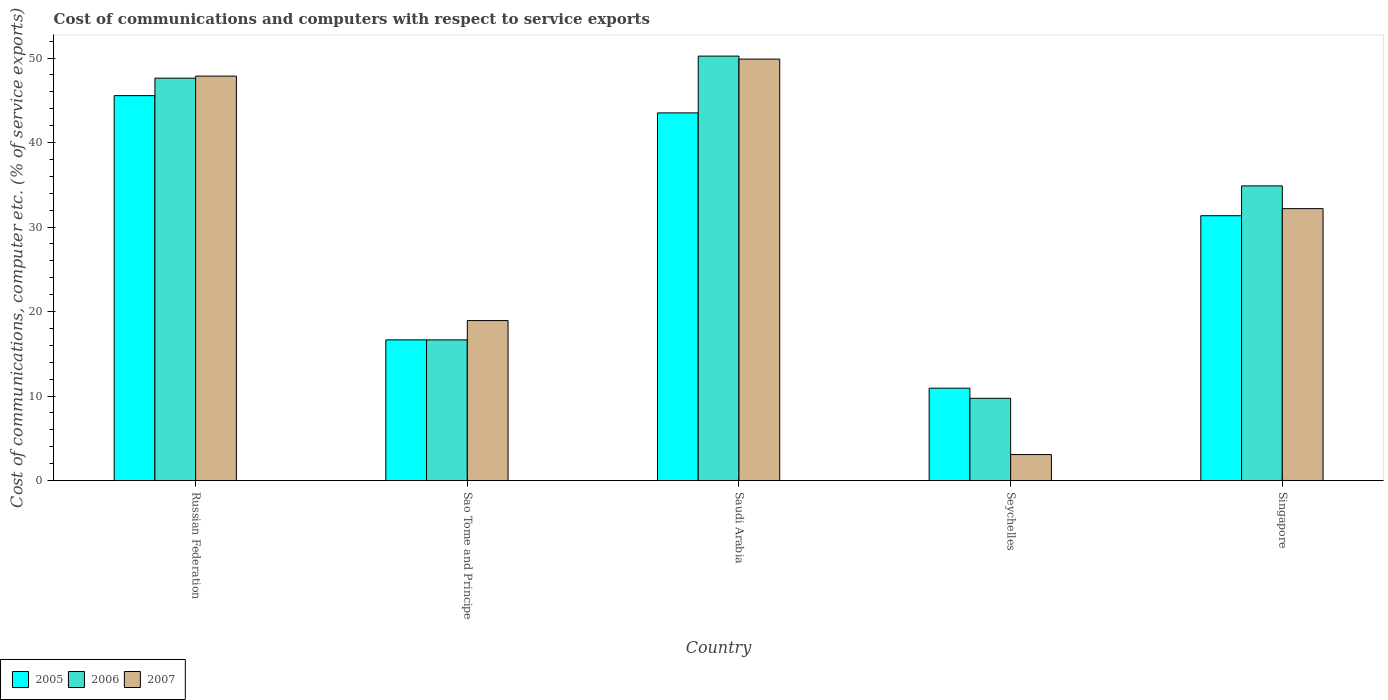Are the number of bars per tick equal to the number of legend labels?
Keep it short and to the point. Yes. How many bars are there on the 3rd tick from the left?
Give a very brief answer. 3. How many bars are there on the 3rd tick from the right?
Provide a short and direct response. 3. What is the label of the 4th group of bars from the left?
Provide a short and direct response. Seychelles. In how many cases, is the number of bars for a given country not equal to the number of legend labels?
Ensure brevity in your answer.  0. What is the cost of communications and computers in 2005 in Sao Tome and Principe?
Keep it short and to the point. 16.65. Across all countries, what is the maximum cost of communications and computers in 2006?
Offer a very short reply. 50.22. Across all countries, what is the minimum cost of communications and computers in 2006?
Your answer should be very brief. 9.74. In which country was the cost of communications and computers in 2006 maximum?
Keep it short and to the point. Saudi Arabia. In which country was the cost of communications and computers in 2007 minimum?
Keep it short and to the point. Seychelles. What is the total cost of communications and computers in 2007 in the graph?
Your answer should be very brief. 151.91. What is the difference between the cost of communications and computers in 2005 in Sao Tome and Principe and that in Saudi Arabia?
Provide a succinct answer. -26.86. What is the difference between the cost of communications and computers in 2006 in Singapore and the cost of communications and computers in 2007 in Russian Federation?
Provide a succinct answer. -12.99. What is the average cost of communications and computers in 2006 per country?
Your answer should be compact. 31.82. What is the difference between the cost of communications and computers of/in 2005 and cost of communications and computers of/in 2006 in Seychelles?
Offer a terse response. 1.2. In how many countries, is the cost of communications and computers in 2007 greater than 4 %?
Give a very brief answer. 4. What is the ratio of the cost of communications and computers in 2005 in Russian Federation to that in Sao Tome and Principe?
Ensure brevity in your answer.  2.74. Is the difference between the cost of communications and computers in 2005 in Saudi Arabia and Singapore greater than the difference between the cost of communications and computers in 2006 in Saudi Arabia and Singapore?
Your answer should be very brief. No. What is the difference between the highest and the second highest cost of communications and computers in 2007?
Your answer should be very brief. -17.69. What is the difference between the highest and the lowest cost of communications and computers in 2006?
Your response must be concise. 40.49. What does the 3rd bar from the right in Sao Tome and Principe represents?
Offer a terse response. 2005. Are all the bars in the graph horizontal?
Ensure brevity in your answer.  No. What is the difference between two consecutive major ticks on the Y-axis?
Provide a short and direct response. 10. Are the values on the major ticks of Y-axis written in scientific E-notation?
Provide a succinct answer. No. Where does the legend appear in the graph?
Keep it short and to the point. Bottom left. How are the legend labels stacked?
Your answer should be compact. Horizontal. What is the title of the graph?
Your response must be concise. Cost of communications and computers with respect to service exports. Does "1974" appear as one of the legend labels in the graph?
Ensure brevity in your answer.  No. What is the label or title of the X-axis?
Keep it short and to the point. Country. What is the label or title of the Y-axis?
Ensure brevity in your answer.  Cost of communications, computer etc. (% of service exports). What is the Cost of communications, computer etc. (% of service exports) of 2005 in Russian Federation?
Your answer should be very brief. 45.55. What is the Cost of communications, computer etc. (% of service exports) of 2006 in Russian Federation?
Provide a short and direct response. 47.61. What is the Cost of communications, computer etc. (% of service exports) of 2007 in Russian Federation?
Provide a succinct answer. 47.86. What is the Cost of communications, computer etc. (% of service exports) in 2005 in Sao Tome and Principe?
Give a very brief answer. 16.65. What is the Cost of communications, computer etc. (% of service exports) in 2006 in Sao Tome and Principe?
Provide a succinct answer. 16.65. What is the Cost of communications, computer etc. (% of service exports) of 2007 in Sao Tome and Principe?
Offer a terse response. 18.93. What is the Cost of communications, computer etc. (% of service exports) in 2005 in Saudi Arabia?
Keep it short and to the point. 43.5. What is the Cost of communications, computer etc. (% of service exports) in 2006 in Saudi Arabia?
Keep it short and to the point. 50.22. What is the Cost of communications, computer etc. (% of service exports) of 2007 in Saudi Arabia?
Provide a succinct answer. 49.87. What is the Cost of communications, computer etc. (% of service exports) in 2005 in Seychelles?
Your answer should be compact. 10.93. What is the Cost of communications, computer etc. (% of service exports) of 2006 in Seychelles?
Your answer should be very brief. 9.74. What is the Cost of communications, computer etc. (% of service exports) of 2007 in Seychelles?
Provide a short and direct response. 3.08. What is the Cost of communications, computer etc. (% of service exports) of 2005 in Singapore?
Give a very brief answer. 31.34. What is the Cost of communications, computer etc. (% of service exports) of 2006 in Singapore?
Give a very brief answer. 34.87. What is the Cost of communications, computer etc. (% of service exports) of 2007 in Singapore?
Make the answer very short. 32.18. Across all countries, what is the maximum Cost of communications, computer etc. (% of service exports) in 2005?
Keep it short and to the point. 45.55. Across all countries, what is the maximum Cost of communications, computer etc. (% of service exports) of 2006?
Ensure brevity in your answer.  50.22. Across all countries, what is the maximum Cost of communications, computer etc. (% of service exports) of 2007?
Make the answer very short. 49.87. Across all countries, what is the minimum Cost of communications, computer etc. (% of service exports) in 2005?
Offer a terse response. 10.93. Across all countries, what is the minimum Cost of communications, computer etc. (% of service exports) of 2006?
Your answer should be very brief. 9.74. Across all countries, what is the minimum Cost of communications, computer etc. (% of service exports) in 2007?
Offer a very short reply. 3.08. What is the total Cost of communications, computer etc. (% of service exports) of 2005 in the graph?
Your answer should be compact. 147.97. What is the total Cost of communications, computer etc. (% of service exports) of 2006 in the graph?
Provide a short and direct response. 159.09. What is the total Cost of communications, computer etc. (% of service exports) in 2007 in the graph?
Give a very brief answer. 151.91. What is the difference between the Cost of communications, computer etc. (% of service exports) in 2005 in Russian Federation and that in Sao Tome and Principe?
Offer a terse response. 28.9. What is the difference between the Cost of communications, computer etc. (% of service exports) of 2006 in Russian Federation and that in Sao Tome and Principe?
Offer a terse response. 30.97. What is the difference between the Cost of communications, computer etc. (% of service exports) of 2007 in Russian Federation and that in Sao Tome and Principe?
Keep it short and to the point. 28.92. What is the difference between the Cost of communications, computer etc. (% of service exports) in 2005 in Russian Federation and that in Saudi Arabia?
Your answer should be compact. 2.04. What is the difference between the Cost of communications, computer etc. (% of service exports) in 2006 in Russian Federation and that in Saudi Arabia?
Your answer should be compact. -2.61. What is the difference between the Cost of communications, computer etc. (% of service exports) in 2007 in Russian Federation and that in Saudi Arabia?
Offer a terse response. -2.01. What is the difference between the Cost of communications, computer etc. (% of service exports) in 2005 in Russian Federation and that in Seychelles?
Ensure brevity in your answer.  34.61. What is the difference between the Cost of communications, computer etc. (% of service exports) of 2006 in Russian Federation and that in Seychelles?
Ensure brevity in your answer.  37.88. What is the difference between the Cost of communications, computer etc. (% of service exports) of 2007 in Russian Federation and that in Seychelles?
Keep it short and to the point. 44.78. What is the difference between the Cost of communications, computer etc. (% of service exports) in 2005 in Russian Federation and that in Singapore?
Offer a terse response. 14.21. What is the difference between the Cost of communications, computer etc. (% of service exports) of 2006 in Russian Federation and that in Singapore?
Offer a terse response. 12.75. What is the difference between the Cost of communications, computer etc. (% of service exports) in 2007 in Russian Federation and that in Singapore?
Keep it short and to the point. 15.68. What is the difference between the Cost of communications, computer etc. (% of service exports) in 2005 in Sao Tome and Principe and that in Saudi Arabia?
Provide a succinct answer. -26.86. What is the difference between the Cost of communications, computer etc. (% of service exports) of 2006 in Sao Tome and Principe and that in Saudi Arabia?
Your response must be concise. -33.58. What is the difference between the Cost of communications, computer etc. (% of service exports) of 2007 in Sao Tome and Principe and that in Saudi Arabia?
Make the answer very short. -30.94. What is the difference between the Cost of communications, computer etc. (% of service exports) in 2005 in Sao Tome and Principe and that in Seychelles?
Provide a succinct answer. 5.72. What is the difference between the Cost of communications, computer etc. (% of service exports) in 2006 in Sao Tome and Principe and that in Seychelles?
Your answer should be compact. 6.91. What is the difference between the Cost of communications, computer etc. (% of service exports) of 2007 in Sao Tome and Principe and that in Seychelles?
Your response must be concise. 15.86. What is the difference between the Cost of communications, computer etc. (% of service exports) of 2005 in Sao Tome and Principe and that in Singapore?
Offer a very short reply. -14.69. What is the difference between the Cost of communications, computer etc. (% of service exports) of 2006 in Sao Tome and Principe and that in Singapore?
Keep it short and to the point. -18.22. What is the difference between the Cost of communications, computer etc. (% of service exports) in 2007 in Sao Tome and Principe and that in Singapore?
Offer a very short reply. -13.24. What is the difference between the Cost of communications, computer etc. (% of service exports) of 2005 in Saudi Arabia and that in Seychelles?
Ensure brevity in your answer.  32.57. What is the difference between the Cost of communications, computer etc. (% of service exports) in 2006 in Saudi Arabia and that in Seychelles?
Your answer should be compact. 40.49. What is the difference between the Cost of communications, computer etc. (% of service exports) in 2007 in Saudi Arabia and that in Seychelles?
Your answer should be very brief. 46.79. What is the difference between the Cost of communications, computer etc. (% of service exports) of 2005 in Saudi Arabia and that in Singapore?
Give a very brief answer. 12.17. What is the difference between the Cost of communications, computer etc. (% of service exports) in 2006 in Saudi Arabia and that in Singapore?
Your response must be concise. 15.36. What is the difference between the Cost of communications, computer etc. (% of service exports) in 2007 in Saudi Arabia and that in Singapore?
Your response must be concise. 17.69. What is the difference between the Cost of communications, computer etc. (% of service exports) of 2005 in Seychelles and that in Singapore?
Provide a succinct answer. -20.41. What is the difference between the Cost of communications, computer etc. (% of service exports) of 2006 in Seychelles and that in Singapore?
Offer a very short reply. -25.13. What is the difference between the Cost of communications, computer etc. (% of service exports) in 2007 in Seychelles and that in Singapore?
Provide a short and direct response. -29.1. What is the difference between the Cost of communications, computer etc. (% of service exports) in 2005 in Russian Federation and the Cost of communications, computer etc. (% of service exports) in 2006 in Sao Tome and Principe?
Your answer should be very brief. 28.9. What is the difference between the Cost of communications, computer etc. (% of service exports) of 2005 in Russian Federation and the Cost of communications, computer etc. (% of service exports) of 2007 in Sao Tome and Principe?
Ensure brevity in your answer.  26.61. What is the difference between the Cost of communications, computer etc. (% of service exports) of 2006 in Russian Federation and the Cost of communications, computer etc. (% of service exports) of 2007 in Sao Tome and Principe?
Your response must be concise. 28.68. What is the difference between the Cost of communications, computer etc. (% of service exports) in 2005 in Russian Federation and the Cost of communications, computer etc. (% of service exports) in 2006 in Saudi Arabia?
Your response must be concise. -4.68. What is the difference between the Cost of communications, computer etc. (% of service exports) of 2005 in Russian Federation and the Cost of communications, computer etc. (% of service exports) of 2007 in Saudi Arabia?
Give a very brief answer. -4.32. What is the difference between the Cost of communications, computer etc. (% of service exports) of 2006 in Russian Federation and the Cost of communications, computer etc. (% of service exports) of 2007 in Saudi Arabia?
Your answer should be compact. -2.26. What is the difference between the Cost of communications, computer etc. (% of service exports) in 2005 in Russian Federation and the Cost of communications, computer etc. (% of service exports) in 2006 in Seychelles?
Your response must be concise. 35.81. What is the difference between the Cost of communications, computer etc. (% of service exports) in 2005 in Russian Federation and the Cost of communications, computer etc. (% of service exports) in 2007 in Seychelles?
Make the answer very short. 42.47. What is the difference between the Cost of communications, computer etc. (% of service exports) of 2006 in Russian Federation and the Cost of communications, computer etc. (% of service exports) of 2007 in Seychelles?
Provide a short and direct response. 44.54. What is the difference between the Cost of communications, computer etc. (% of service exports) of 2005 in Russian Federation and the Cost of communications, computer etc. (% of service exports) of 2006 in Singapore?
Your answer should be compact. 10.68. What is the difference between the Cost of communications, computer etc. (% of service exports) of 2005 in Russian Federation and the Cost of communications, computer etc. (% of service exports) of 2007 in Singapore?
Your answer should be compact. 13.37. What is the difference between the Cost of communications, computer etc. (% of service exports) of 2006 in Russian Federation and the Cost of communications, computer etc. (% of service exports) of 2007 in Singapore?
Keep it short and to the point. 15.44. What is the difference between the Cost of communications, computer etc. (% of service exports) of 2005 in Sao Tome and Principe and the Cost of communications, computer etc. (% of service exports) of 2006 in Saudi Arabia?
Offer a terse response. -33.58. What is the difference between the Cost of communications, computer etc. (% of service exports) in 2005 in Sao Tome and Principe and the Cost of communications, computer etc. (% of service exports) in 2007 in Saudi Arabia?
Provide a succinct answer. -33.22. What is the difference between the Cost of communications, computer etc. (% of service exports) in 2006 in Sao Tome and Principe and the Cost of communications, computer etc. (% of service exports) in 2007 in Saudi Arabia?
Give a very brief answer. -33.22. What is the difference between the Cost of communications, computer etc. (% of service exports) of 2005 in Sao Tome and Principe and the Cost of communications, computer etc. (% of service exports) of 2006 in Seychelles?
Provide a short and direct response. 6.91. What is the difference between the Cost of communications, computer etc. (% of service exports) in 2005 in Sao Tome and Principe and the Cost of communications, computer etc. (% of service exports) in 2007 in Seychelles?
Provide a succinct answer. 13.57. What is the difference between the Cost of communications, computer etc. (% of service exports) in 2006 in Sao Tome and Principe and the Cost of communications, computer etc. (% of service exports) in 2007 in Seychelles?
Offer a very short reply. 13.57. What is the difference between the Cost of communications, computer etc. (% of service exports) in 2005 in Sao Tome and Principe and the Cost of communications, computer etc. (% of service exports) in 2006 in Singapore?
Offer a very short reply. -18.22. What is the difference between the Cost of communications, computer etc. (% of service exports) of 2005 in Sao Tome and Principe and the Cost of communications, computer etc. (% of service exports) of 2007 in Singapore?
Provide a short and direct response. -15.53. What is the difference between the Cost of communications, computer etc. (% of service exports) in 2006 in Sao Tome and Principe and the Cost of communications, computer etc. (% of service exports) in 2007 in Singapore?
Your answer should be compact. -15.53. What is the difference between the Cost of communications, computer etc. (% of service exports) in 2005 in Saudi Arabia and the Cost of communications, computer etc. (% of service exports) in 2006 in Seychelles?
Keep it short and to the point. 33.77. What is the difference between the Cost of communications, computer etc. (% of service exports) of 2005 in Saudi Arabia and the Cost of communications, computer etc. (% of service exports) of 2007 in Seychelles?
Provide a short and direct response. 40.43. What is the difference between the Cost of communications, computer etc. (% of service exports) of 2006 in Saudi Arabia and the Cost of communications, computer etc. (% of service exports) of 2007 in Seychelles?
Offer a terse response. 47.15. What is the difference between the Cost of communications, computer etc. (% of service exports) of 2005 in Saudi Arabia and the Cost of communications, computer etc. (% of service exports) of 2006 in Singapore?
Your response must be concise. 8.64. What is the difference between the Cost of communications, computer etc. (% of service exports) of 2005 in Saudi Arabia and the Cost of communications, computer etc. (% of service exports) of 2007 in Singapore?
Your answer should be compact. 11.33. What is the difference between the Cost of communications, computer etc. (% of service exports) in 2006 in Saudi Arabia and the Cost of communications, computer etc. (% of service exports) in 2007 in Singapore?
Offer a terse response. 18.05. What is the difference between the Cost of communications, computer etc. (% of service exports) in 2005 in Seychelles and the Cost of communications, computer etc. (% of service exports) in 2006 in Singapore?
Your answer should be compact. -23.94. What is the difference between the Cost of communications, computer etc. (% of service exports) in 2005 in Seychelles and the Cost of communications, computer etc. (% of service exports) in 2007 in Singapore?
Your response must be concise. -21.24. What is the difference between the Cost of communications, computer etc. (% of service exports) in 2006 in Seychelles and the Cost of communications, computer etc. (% of service exports) in 2007 in Singapore?
Make the answer very short. -22.44. What is the average Cost of communications, computer etc. (% of service exports) in 2005 per country?
Make the answer very short. 29.59. What is the average Cost of communications, computer etc. (% of service exports) of 2006 per country?
Give a very brief answer. 31.82. What is the average Cost of communications, computer etc. (% of service exports) in 2007 per country?
Your answer should be compact. 30.38. What is the difference between the Cost of communications, computer etc. (% of service exports) of 2005 and Cost of communications, computer etc. (% of service exports) of 2006 in Russian Federation?
Ensure brevity in your answer.  -2.07. What is the difference between the Cost of communications, computer etc. (% of service exports) of 2005 and Cost of communications, computer etc. (% of service exports) of 2007 in Russian Federation?
Offer a very short reply. -2.31. What is the difference between the Cost of communications, computer etc. (% of service exports) in 2006 and Cost of communications, computer etc. (% of service exports) in 2007 in Russian Federation?
Offer a very short reply. -0.24. What is the difference between the Cost of communications, computer etc. (% of service exports) in 2005 and Cost of communications, computer etc. (% of service exports) in 2007 in Sao Tome and Principe?
Keep it short and to the point. -2.29. What is the difference between the Cost of communications, computer etc. (% of service exports) of 2006 and Cost of communications, computer etc. (% of service exports) of 2007 in Sao Tome and Principe?
Make the answer very short. -2.29. What is the difference between the Cost of communications, computer etc. (% of service exports) of 2005 and Cost of communications, computer etc. (% of service exports) of 2006 in Saudi Arabia?
Ensure brevity in your answer.  -6.72. What is the difference between the Cost of communications, computer etc. (% of service exports) of 2005 and Cost of communications, computer etc. (% of service exports) of 2007 in Saudi Arabia?
Provide a succinct answer. -6.37. What is the difference between the Cost of communications, computer etc. (% of service exports) of 2006 and Cost of communications, computer etc. (% of service exports) of 2007 in Saudi Arabia?
Your answer should be compact. 0.36. What is the difference between the Cost of communications, computer etc. (% of service exports) in 2005 and Cost of communications, computer etc. (% of service exports) in 2006 in Seychelles?
Make the answer very short. 1.2. What is the difference between the Cost of communications, computer etc. (% of service exports) in 2005 and Cost of communications, computer etc. (% of service exports) in 2007 in Seychelles?
Your response must be concise. 7.85. What is the difference between the Cost of communications, computer etc. (% of service exports) in 2006 and Cost of communications, computer etc. (% of service exports) in 2007 in Seychelles?
Make the answer very short. 6.66. What is the difference between the Cost of communications, computer etc. (% of service exports) of 2005 and Cost of communications, computer etc. (% of service exports) of 2006 in Singapore?
Your response must be concise. -3.53. What is the difference between the Cost of communications, computer etc. (% of service exports) of 2005 and Cost of communications, computer etc. (% of service exports) of 2007 in Singapore?
Your answer should be very brief. -0.84. What is the difference between the Cost of communications, computer etc. (% of service exports) in 2006 and Cost of communications, computer etc. (% of service exports) in 2007 in Singapore?
Give a very brief answer. 2.69. What is the ratio of the Cost of communications, computer etc. (% of service exports) of 2005 in Russian Federation to that in Sao Tome and Principe?
Provide a short and direct response. 2.74. What is the ratio of the Cost of communications, computer etc. (% of service exports) of 2006 in Russian Federation to that in Sao Tome and Principe?
Your answer should be compact. 2.86. What is the ratio of the Cost of communications, computer etc. (% of service exports) of 2007 in Russian Federation to that in Sao Tome and Principe?
Your response must be concise. 2.53. What is the ratio of the Cost of communications, computer etc. (% of service exports) in 2005 in Russian Federation to that in Saudi Arabia?
Keep it short and to the point. 1.05. What is the ratio of the Cost of communications, computer etc. (% of service exports) of 2006 in Russian Federation to that in Saudi Arabia?
Offer a terse response. 0.95. What is the ratio of the Cost of communications, computer etc. (% of service exports) of 2007 in Russian Federation to that in Saudi Arabia?
Provide a short and direct response. 0.96. What is the ratio of the Cost of communications, computer etc. (% of service exports) in 2005 in Russian Federation to that in Seychelles?
Your response must be concise. 4.17. What is the ratio of the Cost of communications, computer etc. (% of service exports) of 2006 in Russian Federation to that in Seychelles?
Your response must be concise. 4.89. What is the ratio of the Cost of communications, computer etc. (% of service exports) in 2007 in Russian Federation to that in Seychelles?
Give a very brief answer. 15.55. What is the ratio of the Cost of communications, computer etc. (% of service exports) of 2005 in Russian Federation to that in Singapore?
Your answer should be very brief. 1.45. What is the ratio of the Cost of communications, computer etc. (% of service exports) of 2006 in Russian Federation to that in Singapore?
Ensure brevity in your answer.  1.37. What is the ratio of the Cost of communications, computer etc. (% of service exports) of 2007 in Russian Federation to that in Singapore?
Offer a very short reply. 1.49. What is the ratio of the Cost of communications, computer etc. (% of service exports) of 2005 in Sao Tome and Principe to that in Saudi Arabia?
Keep it short and to the point. 0.38. What is the ratio of the Cost of communications, computer etc. (% of service exports) in 2006 in Sao Tome and Principe to that in Saudi Arabia?
Provide a short and direct response. 0.33. What is the ratio of the Cost of communications, computer etc. (% of service exports) of 2007 in Sao Tome and Principe to that in Saudi Arabia?
Your answer should be very brief. 0.38. What is the ratio of the Cost of communications, computer etc. (% of service exports) of 2005 in Sao Tome and Principe to that in Seychelles?
Your answer should be compact. 1.52. What is the ratio of the Cost of communications, computer etc. (% of service exports) of 2006 in Sao Tome and Principe to that in Seychelles?
Keep it short and to the point. 1.71. What is the ratio of the Cost of communications, computer etc. (% of service exports) in 2007 in Sao Tome and Principe to that in Seychelles?
Offer a terse response. 6.15. What is the ratio of the Cost of communications, computer etc. (% of service exports) of 2005 in Sao Tome and Principe to that in Singapore?
Your answer should be very brief. 0.53. What is the ratio of the Cost of communications, computer etc. (% of service exports) in 2006 in Sao Tome and Principe to that in Singapore?
Your answer should be very brief. 0.48. What is the ratio of the Cost of communications, computer etc. (% of service exports) in 2007 in Sao Tome and Principe to that in Singapore?
Offer a very short reply. 0.59. What is the ratio of the Cost of communications, computer etc. (% of service exports) in 2005 in Saudi Arabia to that in Seychelles?
Give a very brief answer. 3.98. What is the ratio of the Cost of communications, computer etc. (% of service exports) of 2006 in Saudi Arabia to that in Seychelles?
Offer a very short reply. 5.16. What is the ratio of the Cost of communications, computer etc. (% of service exports) of 2007 in Saudi Arabia to that in Seychelles?
Keep it short and to the point. 16.2. What is the ratio of the Cost of communications, computer etc. (% of service exports) in 2005 in Saudi Arabia to that in Singapore?
Ensure brevity in your answer.  1.39. What is the ratio of the Cost of communications, computer etc. (% of service exports) of 2006 in Saudi Arabia to that in Singapore?
Keep it short and to the point. 1.44. What is the ratio of the Cost of communications, computer etc. (% of service exports) of 2007 in Saudi Arabia to that in Singapore?
Offer a very short reply. 1.55. What is the ratio of the Cost of communications, computer etc. (% of service exports) in 2005 in Seychelles to that in Singapore?
Your answer should be compact. 0.35. What is the ratio of the Cost of communications, computer etc. (% of service exports) of 2006 in Seychelles to that in Singapore?
Make the answer very short. 0.28. What is the ratio of the Cost of communications, computer etc. (% of service exports) of 2007 in Seychelles to that in Singapore?
Keep it short and to the point. 0.1. What is the difference between the highest and the second highest Cost of communications, computer etc. (% of service exports) of 2005?
Your answer should be very brief. 2.04. What is the difference between the highest and the second highest Cost of communications, computer etc. (% of service exports) of 2006?
Give a very brief answer. 2.61. What is the difference between the highest and the second highest Cost of communications, computer etc. (% of service exports) in 2007?
Your response must be concise. 2.01. What is the difference between the highest and the lowest Cost of communications, computer etc. (% of service exports) of 2005?
Provide a succinct answer. 34.61. What is the difference between the highest and the lowest Cost of communications, computer etc. (% of service exports) in 2006?
Provide a short and direct response. 40.49. What is the difference between the highest and the lowest Cost of communications, computer etc. (% of service exports) in 2007?
Offer a very short reply. 46.79. 